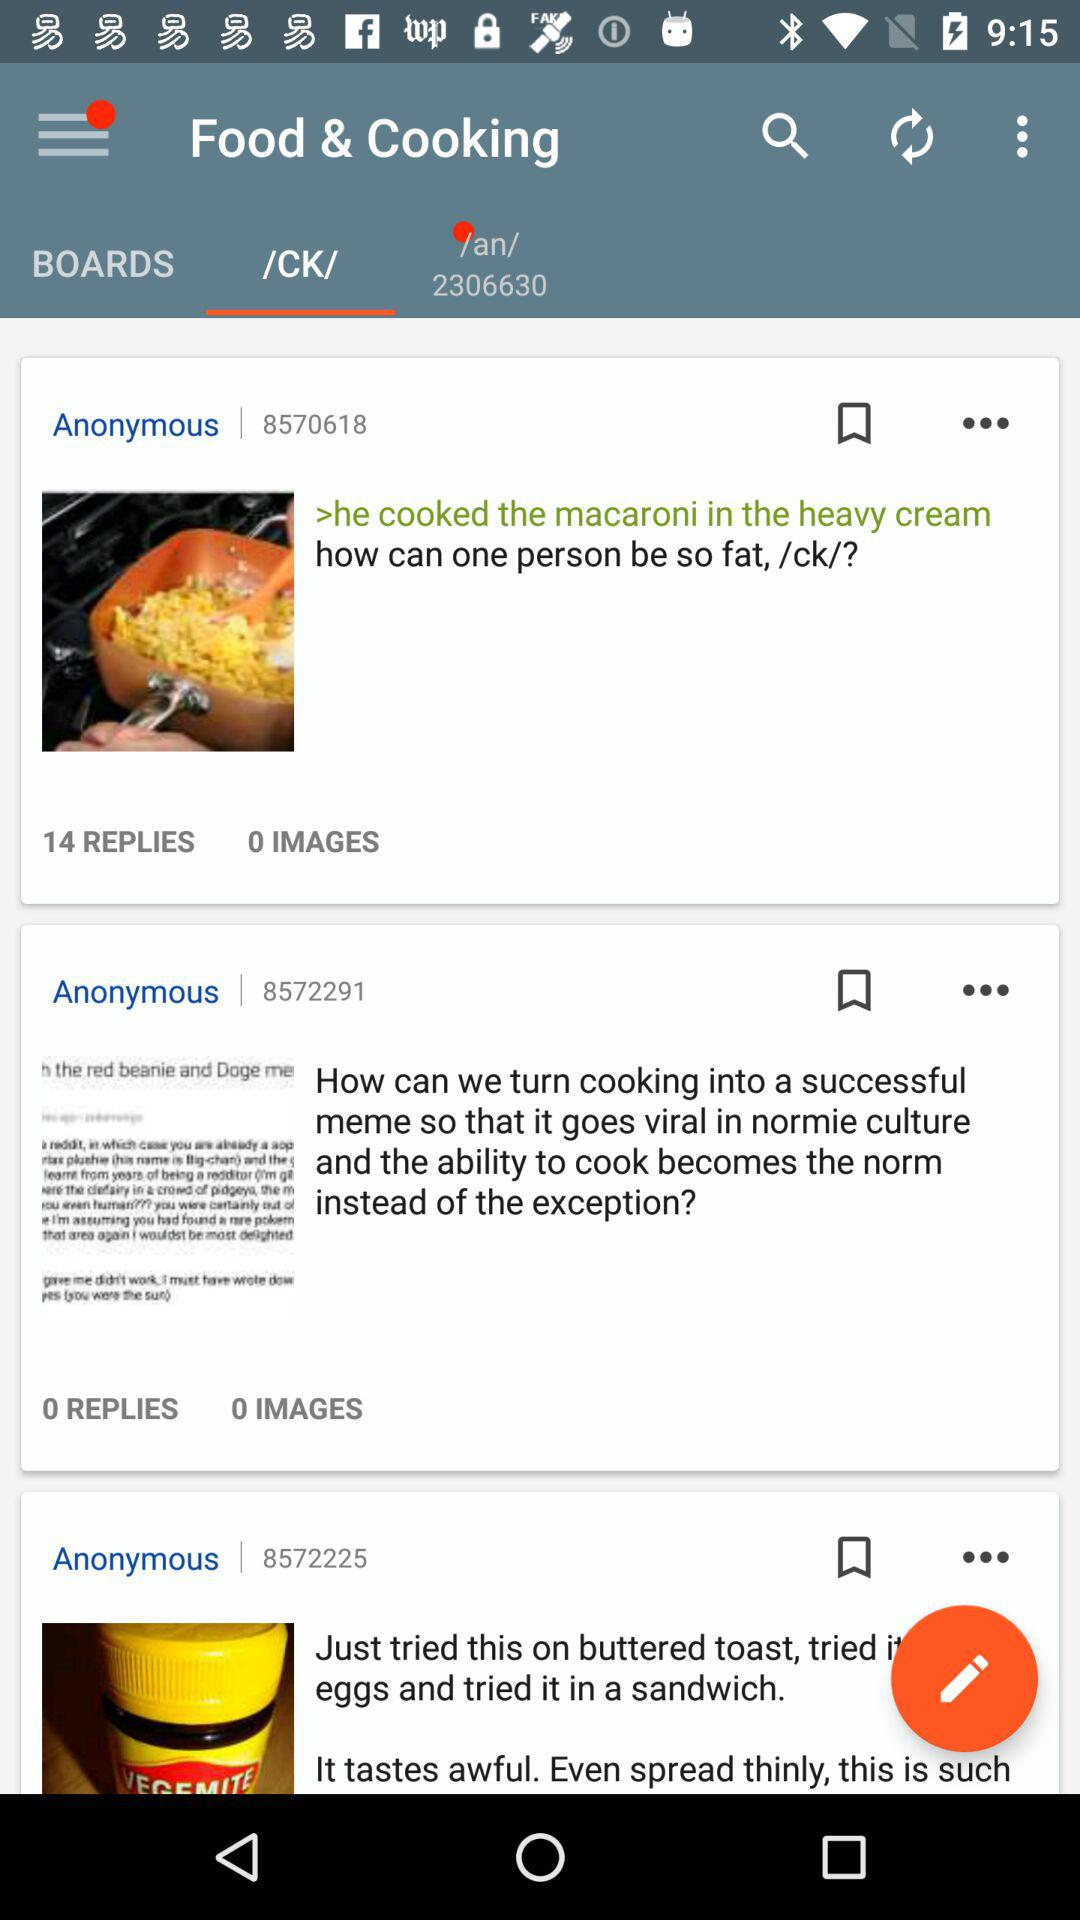How many images are there in "how can one person be so fat"? There are 0 images in "how can one person be so fat". 